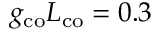<formula> <loc_0><loc_0><loc_500><loc_500>g _ { c o } L _ { c o } = 0 . 3</formula> 